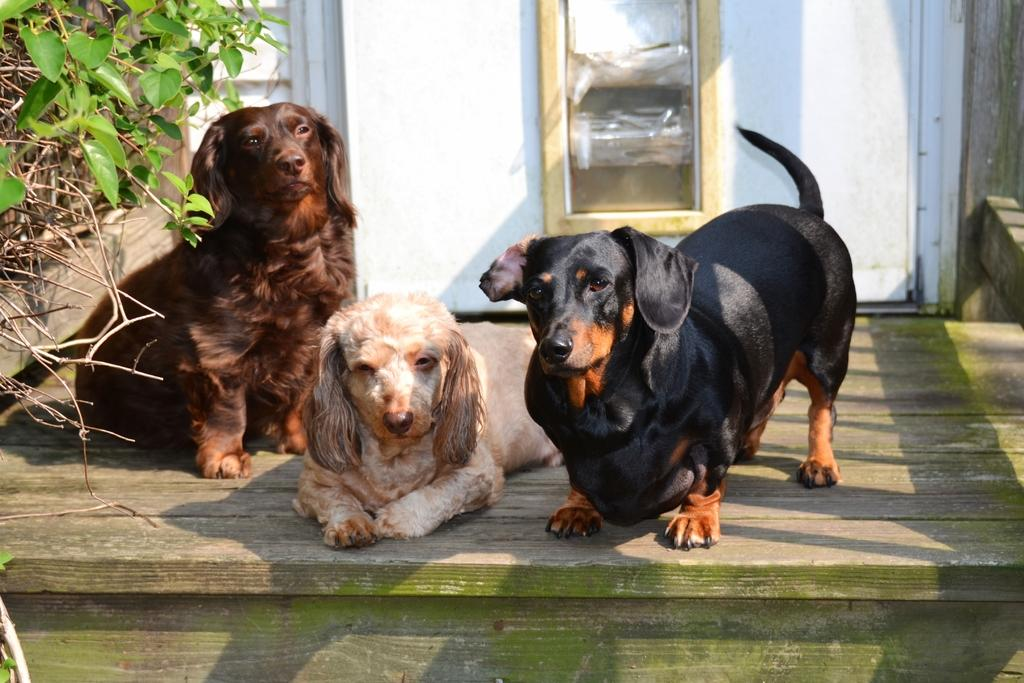What animals are in the center of the image? There are three dogs in the center of the image. What can be seen on the left side of the image? There are plants on the left side of the image. What architectural feature is visible in the background of the image? There is a door visible in the background of the image. What is the weather like in the image? The image appears to be taken on a sunny day. What type of jar is being used by the dogs in the image? There is no jar present in the image; it features three dogs and plants. How do the dogs walk in the image? The dogs are not walking in the image; they are stationary in the center of the image. 